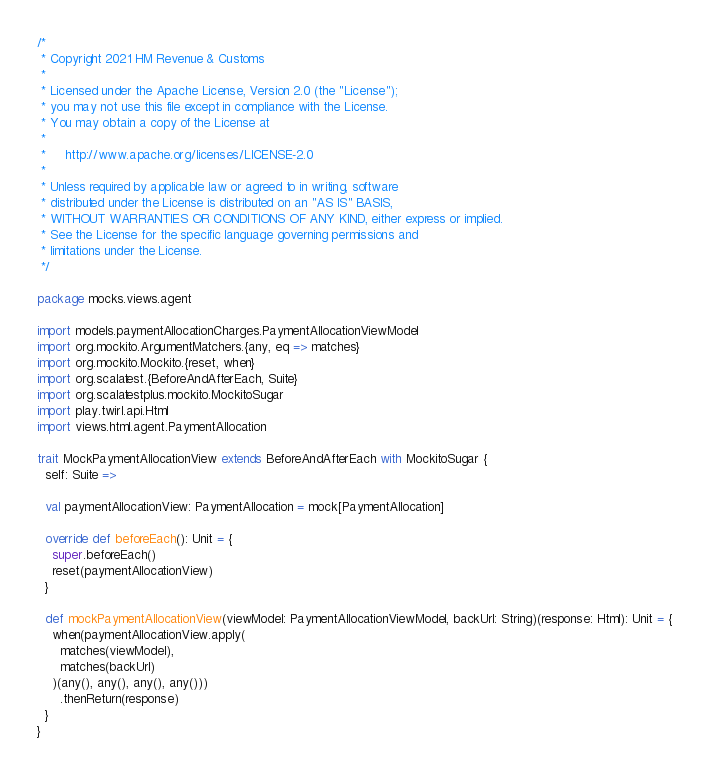<code> <loc_0><loc_0><loc_500><loc_500><_Scala_>/*
 * Copyright 2021 HM Revenue & Customs
 *
 * Licensed under the Apache License, Version 2.0 (the "License");
 * you may not use this file except in compliance with the License.
 * You may obtain a copy of the License at
 *
 *     http://www.apache.org/licenses/LICENSE-2.0
 *
 * Unless required by applicable law or agreed to in writing, software
 * distributed under the License is distributed on an "AS IS" BASIS,
 * WITHOUT WARRANTIES OR CONDITIONS OF ANY KIND, either express or implied.
 * See the License for the specific language governing permissions and
 * limitations under the License.
 */

package mocks.views.agent

import models.paymentAllocationCharges.PaymentAllocationViewModel
import org.mockito.ArgumentMatchers.{any, eq => matches}
import org.mockito.Mockito.{reset, when}
import org.scalatest.{BeforeAndAfterEach, Suite}
import org.scalatestplus.mockito.MockitoSugar
import play.twirl.api.Html
import views.html.agent.PaymentAllocation

trait MockPaymentAllocationView extends BeforeAndAfterEach with MockitoSugar {
  self: Suite =>

  val paymentAllocationView: PaymentAllocation = mock[PaymentAllocation]

  override def beforeEach(): Unit = {
    super.beforeEach()
    reset(paymentAllocationView)
  }

  def mockPaymentAllocationView(viewModel: PaymentAllocationViewModel, backUrl: String)(response: Html): Unit = {
    when(paymentAllocationView.apply(
      matches(viewModel),
      matches(backUrl)
    )(any(), any(), any(), any()))
      .thenReturn(response)
  }
}
</code> 